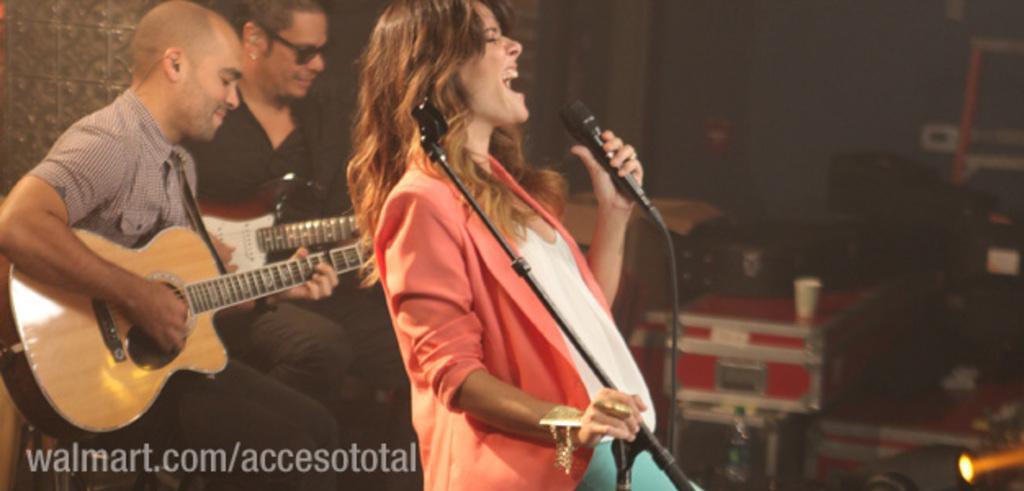Describe this image in one or two sentences. This picture is taken in a room, In the left side there are two people siting and holding some instruments and in the middle there is a woman, She is holding a microphone which is in black color, She is singing, In the background there are some objects which are in red color and there are some music instruments which are in black color. 